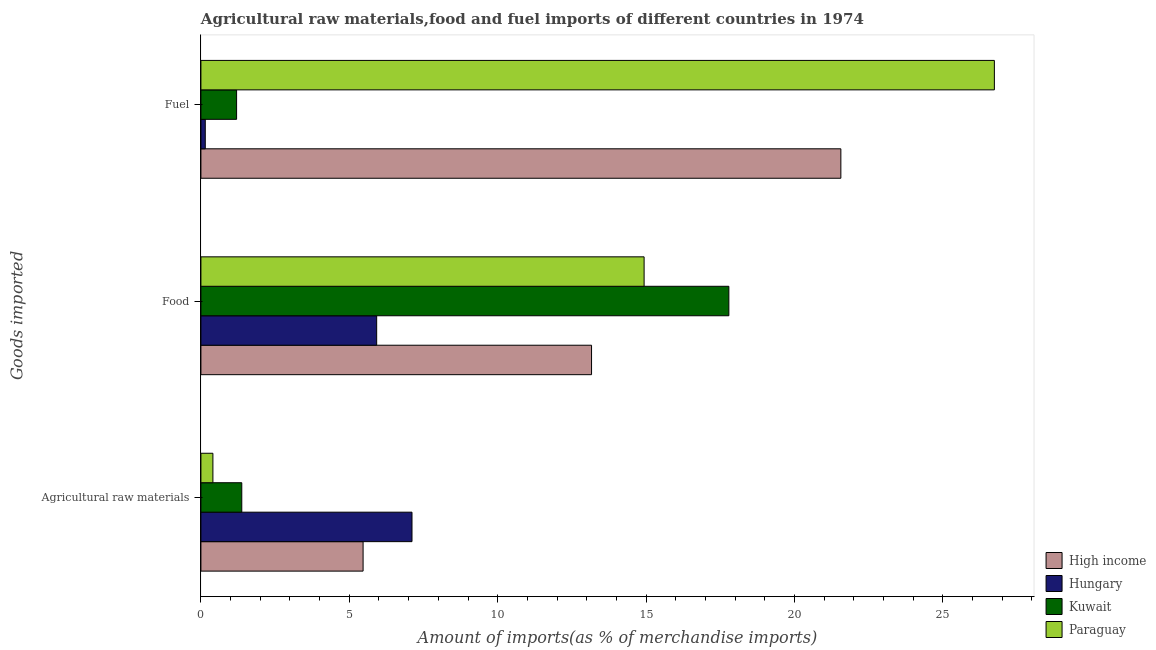How many different coloured bars are there?
Ensure brevity in your answer.  4. How many groups of bars are there?
Your answer should be compact. 3. Are the number of bars per tick equal to the number of legend labels?
Provide a short and direct response. Yes. How many bars are there on the 1st tick from the top?
Offer a terse response. 4. What is the label of the 1st group of bars from the top?
Give a very brief answer. Fuel. What is the percentage of food imports in High income?
Give a very brief answer. 13.16. Across all countries, what is the maximum percentage of food imports?
Provide a succinct answer. 17.79. Across all countries, what is the minimum percentage of fuel imports?
Provide a succinct answer. 0.15. In which country was the percentage of food imports maximum?
Provide a short and direct response. Kuwait. In which country was the percentage of fuel imports minimum?
Keep it short and to the point. Hungary. What is the total percentage of raw materials imports in the graph?
Your response must be concise. 14.36. What is the difference between the percentage of fuel imports in Kuwait and that in High income?
Offer a very short reply. -20.36. What is the difference between the percentage of food imports in Hungary and the percentage of raw materials imports in Paraguay?
Keep it short and to the point. 5.52. What is the average percentage of food imports per country?
Your answer should be very brief. 12.95. What is the difference between the percentage of fuel imports and percentage of food imports in Kuwait?
Make the answer very short. -16.59. What is the ratio of the percentage of raw materials imports in Kuwait to that in Paraguay?
Provide a short and direct response. 3.41. Is the difference between the percentage of raw materials imports in High income and Kuwait greater than the difference between the percentage of food imports in High income and Kuwait?
Provide a short and direct response. Yes. What is the difference between the highest and the second highest percentage of food imports?
Your response must be concise. 2.86. What is the difference between the highest and the lowest percentage of raw materials imports?
Ensure brevity in your answer.  6.71. What does the 2nd bar from the top in Food represents?
Your response must be concise. Kuwait. What does the 2nd bar from the bottom in Agricultural raw materials represents?
Give a very brief answer. Hungary. How many countries are there in the graph?
Your answer should be very brief. 4. What is the difference between two consecutive major ticks on the X-axis?
Your answer should be very brief. 5. Does the graph contain any zero values?
Offer a terse response. No. Where does the legend appear in the graph?
Keep it short and to the point. Bottom right. What is the title of the graph?
Offer a very short reply. Agricultural raw materials,food and fuel imports of different countries in 1974. What is the label or title of the X-axis?
Provide a succinct answer. Amount of imports(as % of merchandise imports). What is the label or title of the Y-axis?
Give a very brief answer. Goods imported. What is the Amount of imports(as % of merchandise imports) of High income in Agricultural raw materials?
Your response must be concise. 5.46. What is the Amount of imports(as % of merchandise imports) of Hungary in Agricultural raw materials?
Keep it short and to the point. 7.11. What is the Amount of imports(as % of merchandise imports) in Kuwait in Agricultural raw materials?
Ensure brevity in your answer.  1.38. What is the Amount of imports(as % of merchandise imports) of Paraguay in Agricultural raw materials?
Your answer should be compact. 0.4. What is the Amount of imports(as % of merchandise imports) of High income in Food?
Offer a terse response. 13.16. What is the Amount of imports(as % of merchandise imports) of Hungary in Food?
Your answer should be very brief. 5.92. What is the Amount of imports(as % of merchandise imports) of Kuwait in Food?
Give a very brief answer. 17.79. What is the Amount of imports(as % of merchandise imports) in Paraguay in Food?
Offer a terse response. 14.93. What is the Amount of imports(as % of merchandise imports) of High income in Fuel?
Your answer should be compact. 21.56. What is the Amount of imports(as % of merchandise imports) of Hungary in Fuel?
Provide a short and direct response. 0.15. What is the Amount of imports(as % of merchandise imports) of Kuwait in Fuel?
Give a very brief answer. 1.2. What is the Amount of imports(as % of merchandise imports) of Paraguay in Fuel?
Keep it short and to the point. 26.74. Across all Goods imported, what is the maximum Amount of imports(as % of merchandise imports) in High income?
Give a very brief answer. 21.56. Across all Goods imported, what is the maximum Amount of imports(as % of merchandise imports) of Hungary?
Provide a succinct answer. 7.11. Across all Goods imported, what is the maximum Amount of imports(as % of merchandise imports) of Kuwait?
Offer a very short reply. 17.79. Across all Goods imported, what is the maximum Amount of imports(as % of merchandise imports) in Paraguay?
Your response must be concise. 26.74. Across all Goods imported, what is the minimum Amount of imports(as % of merchandise imports) of High income?
Provide a succinct answer. 5.46. Across all Goods imported, what is the minimum Amount of imports(as % of merchandise imports) of Hungary?
Offer a very short reply. 0.15. Across all Goods imported, what is the minimum Amount of imports(as % of merchandise imports) in Kuwait?
Your answer should be compact. 1.2. Across all Goods imported, what is the minimum Amount of imports(as % of merchandise imports) in Paraguay?
Keep it short and to the point. 0.4. What is the total Amount of imports(as % of merchandise imports) in High income in the graph?
Give a very brief answer. 40.19. What is the total Amount of imports(as % of merchandise imports) in Hungary in the graph?
Your answer should be compact. 13.18. What is the total Amount of imports(as % of merchandise imports) of Kuwait in the graph?
Your response must be concise. 20.37. What is the total Amount of imports(as % of merchandise imports) of Paraguay in the graph?
Make the answer very short. 42.07. What is the difference between the Amount of imports(as % of merchandise imports) of High income in Agricultural raw materials and that in Food?
Provide a succinct answer. -7.7. What is the difference between the Amount of imports(as % of merchandise imports) of Hungary in Agricultural raw materials and that in Food?
Offer a terse response. 1.19. What is the difference between the Amount of imports(as % of merchandise imports) of Kuwait in Agricultural raw materials and that in Food?
Ensure brevity in your answer.  -16.41. What is the difference between the Amount of imports(as % of merchandise imports) in Paraguay in Agricultural raw materials and that in Food?
Provide a succinct answer. -14.53. What is the difference between the Amount of imports(as % of merchandise imports) of High income in Agricultural raw materials and that in Fuel?
Offer a terse response. -16.1. What is the difference between the Amount of imports(as % of merchandise imports) in Hungary in Agricultural raw materials and that in Fuel?
Ensure brevity in your answer.  6.97. What is the difference between the Amount of imports(as % of merchandise imports) of Kuwait in Agricultural raw materials and that in Fuel?
Your answer should be compact. 0.17. What is the difference between the Amount of imports(as % of merchandise imports) in Paraguay in Agricultural raw materials and that in Fuel?
Keep it short and to the point. -26.33. What is the difference between the Amount of imports(as % of merchandise imports) in High income in Food and that in Fuel?
Ensure brevity in your answer.  -8.4. What is the difference between the Amount of imports(as % of merchandise imports) of Hungary in Food and that in Fuel?
Your answer should be very brief. 5.78. What is the difference between the Amount of imports(as % of merchandise imports) in Kuwait in Food and that in Fuel?
Offer a very short reply. 16.59. What is the difference between the Amount of imports(as % of merchandise imports) of Paraguay in Food and that in Fuel?
Make the answer very short. -11.8. What is the difference between the Amount of imports(as % of merchandise imports) in High income in Agricultural raw materials and the Amount of imports(as % of merchandise imports) in Hungary in Food?
Make the answer very short. -0.46. What is the difference between the Amount of imports(as % of merchandise imports) of High income in Agricultural raw materials and the Amount of imports(as % of merchandise imports) of Kuwait in Food?
Your answer should be compact. -12.32. What is the difference between the Amount of imports(as % of merchandise imports) in High income in Agricultural raw materials and the Amount of imports(as % of merchandise imports) in Paraguay in Food?
Provide a short and direct response. -9.47. What is the difference between the Amount of imports(as % of merchandise imports) of Hungary in Agricultural raw materials and the Amount of imports(as % of merchandise imports) of Kuwait in Food?
Keep it short and to the point. -10.68. What is the difference between the Amount of imports(as % of merchandise imports) in Hungary in Agricultural raw materials and the Amount of imports(as % of merchandise imports) in Paraguay in Food?
Keep it short and to the point. -7.82. What is the difference between the Amount of imports(as % of merchandise imports) in Kuwait in Agricultural raw materials and the Amount of imports(as % of merchandise imports) in Paraguay in Food?
Your answer should be very brief. -13.56. What is the difference between the Amount of imports(as % of merchandise imports) in High income in Agricultural raw materials and the Amount of imports(as % of merchandise imports) in Hungary in Fuel?
Ensure brevity in your answer.  5.32. What is the difference between the Amount of imports(as % of merchandise imports) of High income in Agricultural raw materials and the Amount of imports(as % of merchandise imports) of Kuwait in Fuel?
Make the answer very short. 4.26. What is the difference between the Amount of imports(as % of merchandise imports) of High income in Agricultural raw materials and the Amount of imports(as % of merchandise imports) of Paraguay in Fuel?
Your answer should be very brief. -21.27. What is the difference between the Amount of imports(as % of merchandise imports) in Hungary in Agricultural raw materials and the Amount of imports(as % of merchandise imports) in Kuwait in Fuel?
Keep it short and to the point. 5.91. What is the difference between the Amount of imports(as % of merchandise imports) of Hungary in Agricultural raw materials and the Amount of imports(as % of merchandise imports) of Paraguay in Fuel?
Ensure brevity in your answer.  -19.62. What is the difference between the Amount of imports(as % of merchandise imports) in Kuwait in Agricultural raw materials and the Amount of imports(as % of merchandise imports) in Paraguay in Fuel?
Make the answer very short. -25.36. What is the difference between the Amount of imports(as % of merchandise imports) of High income in Food and the Amount of imports(as % of merchandise imports) of Hungary in Fuel?
Give a very brief answer. 13.02. What is the difference between the Amount of imports(as % of merchandise imports) of High income in Food and the Amount of imports(as % of merchandise imports) of Kuwait in Fuel?
Make the answer very short. 11.96. What is the difference between the Amount of imports(as % of merchandise imports) of High income in Food and the Amount of imports(as % of merchandise imports) of Paraguay in Fuel?
Your answer should be very brief. -13.57. What is the difference between the Amount of imports(as % of merchandise imports) of Hungary in Food and the Amount of imports(as % of merchandise imports) of Kuwait in Fuel?
Make the answer very short. 4.72. What is the difference between the Amount of imports(as % of merchandise imports) of Hungary in Food and the Amount of imports(as % of merchandise imports) of Paraguay in Fuel?
Offer a very short reply. -20.81. What is the difference between the Amount of imports(as % of merchandise imports) of Kuwait in Food and the Amount of imports(as % of merchandise imports) of Paraguay in Fuel?
Offer a very short reply. -8.95. What is the average Amount of imports(as % of merchandise imports) in High income per Goods imported?
Keep it short and to the point. 13.4. What is the average Amount of imports(as % of merchandise imports) of Hungary per Goods imported?
Provide a short and direct response. 4.39. What is the average Amount of imports(as % of merchandise imports) in Kuwait per Goods imported?
Make the answer very short. 6.79. What is the average Amount of imports(as % of merchandise imports) in Paraguay per Goods imported?
Your answer should be compact. 14.02. What is the difference between the Amount of imports(as % of merchandise imports) of High income and Amount of imports(as % of merchandise imports) of Hungary in Agricultural raw materials?
Make the answer very short. -1.65. What is the difference between the Amount of imports(as % of merchandise imports) in High income and Amount of imports(as % of merchandise imports) in Kuwait in Agricultural raw materials?
Make the answer very short. 4.09. What is the difference between the Amount of imports(as % of merchandise imports) of High income and Amount of imports(as % of merchandise imports) of Paraguay in Agricultural raw materials?
Your answer should be compact. 5.06. What is the difference between the Amount of imports(as % of merchandise imports) of Hungary and Amount of imports(as % of merchandise imports) of Kuwait in Agricultural raw materials?
Your response must be concise. 5.74. What is the difference between the Amount of imports(as % of merchandise imports) in Hungary and Amount of imports(as % of merchandise imports) in Paraguay in Agricultural raw materials?
Make the answer very short. 6.71. What is the difference between the Amount of imports(as % of merchandise imports) in Kuwait and Amount of imports(as % of merchandise imports) in Paraguay in Agricultural raw materials?
Make the answer very short. 0.97. What is the difference between the Amount of imports(as % of merchandise imports) of High income and Amount of imports(as % of merchandise imports) of Hungary in Food?
Give a very brief answer. 7.24. What is the difference between the Amount of imports(as % of merchandise imports) in High income and Amount of imports(as % of merchandise imports) in Kuwait in Food?
Keep it short and to the point. -4.63. What is the difference between the Amount of imports(as % of merchandise imports) in High income and Amount of imports(as % of merchandise imports) in Paraguay in Food?
Your answer should be compact. -1.77. What is the difference between the Amount of imports(as % of merchandise imports) in Hungary and Amount of imports(as % of merchandise imports) in Kuwait in Food?
Provide a short and direct response. -11.87. What is the difference between the Amount of imports(as % of merchandise imports) of Hungary and Amount of imports(as % of merchandise imports) of Paraguay in Food?
Offer a terse response. -9.01. What is the difference between the Amount of imports(as % of merchandise imports) in Kuwait and Amount of imports(as % of merchandise imports) in Paraguay in Food?
Provide a short and direct response. 2.86. What is the difference between the Amount of imports(as % of merchandise imports) of High income and Amount of imports(as % of merchandise imports) of Hungary in Fuel?
Ensure brevity in your answer.  21.42. What is the difference between the Amount of imports(as % of merchandise imports) of High income and Amount of imports(as % of merchandise imports) of Kuwait in Fuel?
Your answer should be compact. 20.36. What is the difference between the Amount of imports(as % of merchandise imports) in High income and Amount of imports(as % of merchandise imports) in Paraguay in Fuel?
Ensure brevity in your answer.  -5.17. What is the difference between the Amount of imports(as % of merchandise imports) of Hungary and Amount of imports(as % of merchandise imports) of Kuwait in Fuel?
Give a very brief answer. -1.06. What is the difference between the Amount of imports(as % of merchandise imports) of Hungary and Amount of imports(as % of merchandise imports) of Paraguay in Fuel?
Give a very brief answer. -26.59. What is the difference between the Amount of imports(as % of merchandise imports) of Kuwait and Amount of imports(as % of merchandise imports) of Paraguay in Fuel?
Give a very brief answer. -25.53. What is the ratio of the Amount of imports(as % of merchandise imports) of High income in Agricultural raw materials to that in Food?
Provide a short and direct response. 0.42. What is the ratio of the Amount of imports(as % of merchandise imports) of Hungary in Agricultural raw materials to that in Food?
Keep it short and to the point. 1.2. What is the ratio of the Amount of imports(as % of merchandise imports) in Kuwait in Agricultural raw materials to that in Food?
Offer a terse response. 0.08. What is the ratio of the Amount of imports(as % of merchandise imports) of Paraguay in Agricultural raw materials to that in Food?
Your answer should be compact. 0.03. What is the ratio of the Amount of imports(as % of merchandise imports) of High income in Agricultural raw materials to that in Fuel?
Provide a succinct answer. 0.25. What is the ratio of the Amount of imports(as % of merchandise imports) in Hungary in Agricultural raw materials to that in Fuel?
Make the answer very short. 48.38. What is the ratio of the Amount of imports(as % of merchandise imports) of Kuwait in Agricultural raw materials to that in Fuel?
Your response must be concise. 1.15. What is the ratio of the Amount of imports(as % of merchandise imports) of Paraguay in Agricultural raw materials to that in Fuel?
Your answer should be compact. 0.02. What is the ratio of the Amount of imports(as % of merchandise imports) of High income in Food to that in Fuel?
Your answer should be compact. 0.61. What is the ratio of the Amount of imports(as % of merchandise imports) in Hungary in Food to that in Fuel?
Provide a short and direct response. 40.28. What is the ratio of the Amount of imports(as % of merchandise imports) of Kuwait in Food to that in Fuel?
Provide a short and direct response. 14.8. What is the ratio of the Amount of imports(as % of merchandise imports) in Paraguay in Food to that in Fuel?
Your answer should be very brief. 0.56. What is the difference between the highest and the second highest Amount of imports(as % of merchandise imports) of High income?
Make the answer very short. 8.4. What is the difference between the highest and the second highest Amount of imports(as % of merchandise imports) of Hungary?
Your answer should be very brief. 1.19. What is the difference between the highest and the second highest Amount of imports(as % of merchandise imports) in Kuwait?
Make the answer very short. 16.41. What is the difference between the highest and the second highest Amount of imports(as % of merchandise imports) of Paraguay?
Make the answer very short. 11.8. What is the difference between the highest and the lowest Amount of imports(as % of merchandise imports) in High income?
Keep it short and to the point. 16.1. What is the difference between the highest and the lowest Amount of imports(as % of merchandise imports) in Hungary?
Offer a very short reply. 6.97. What is the difference between the highest and the lowest Amount of imports(as % of merchandise imports) of Kuwait?
Provide a succinct answer. 16.59. What is the difference between the highest and the lowest Amount of imports(as % of merchandise imports) of Paraguay?
Your answer should be compact. 26.33. 